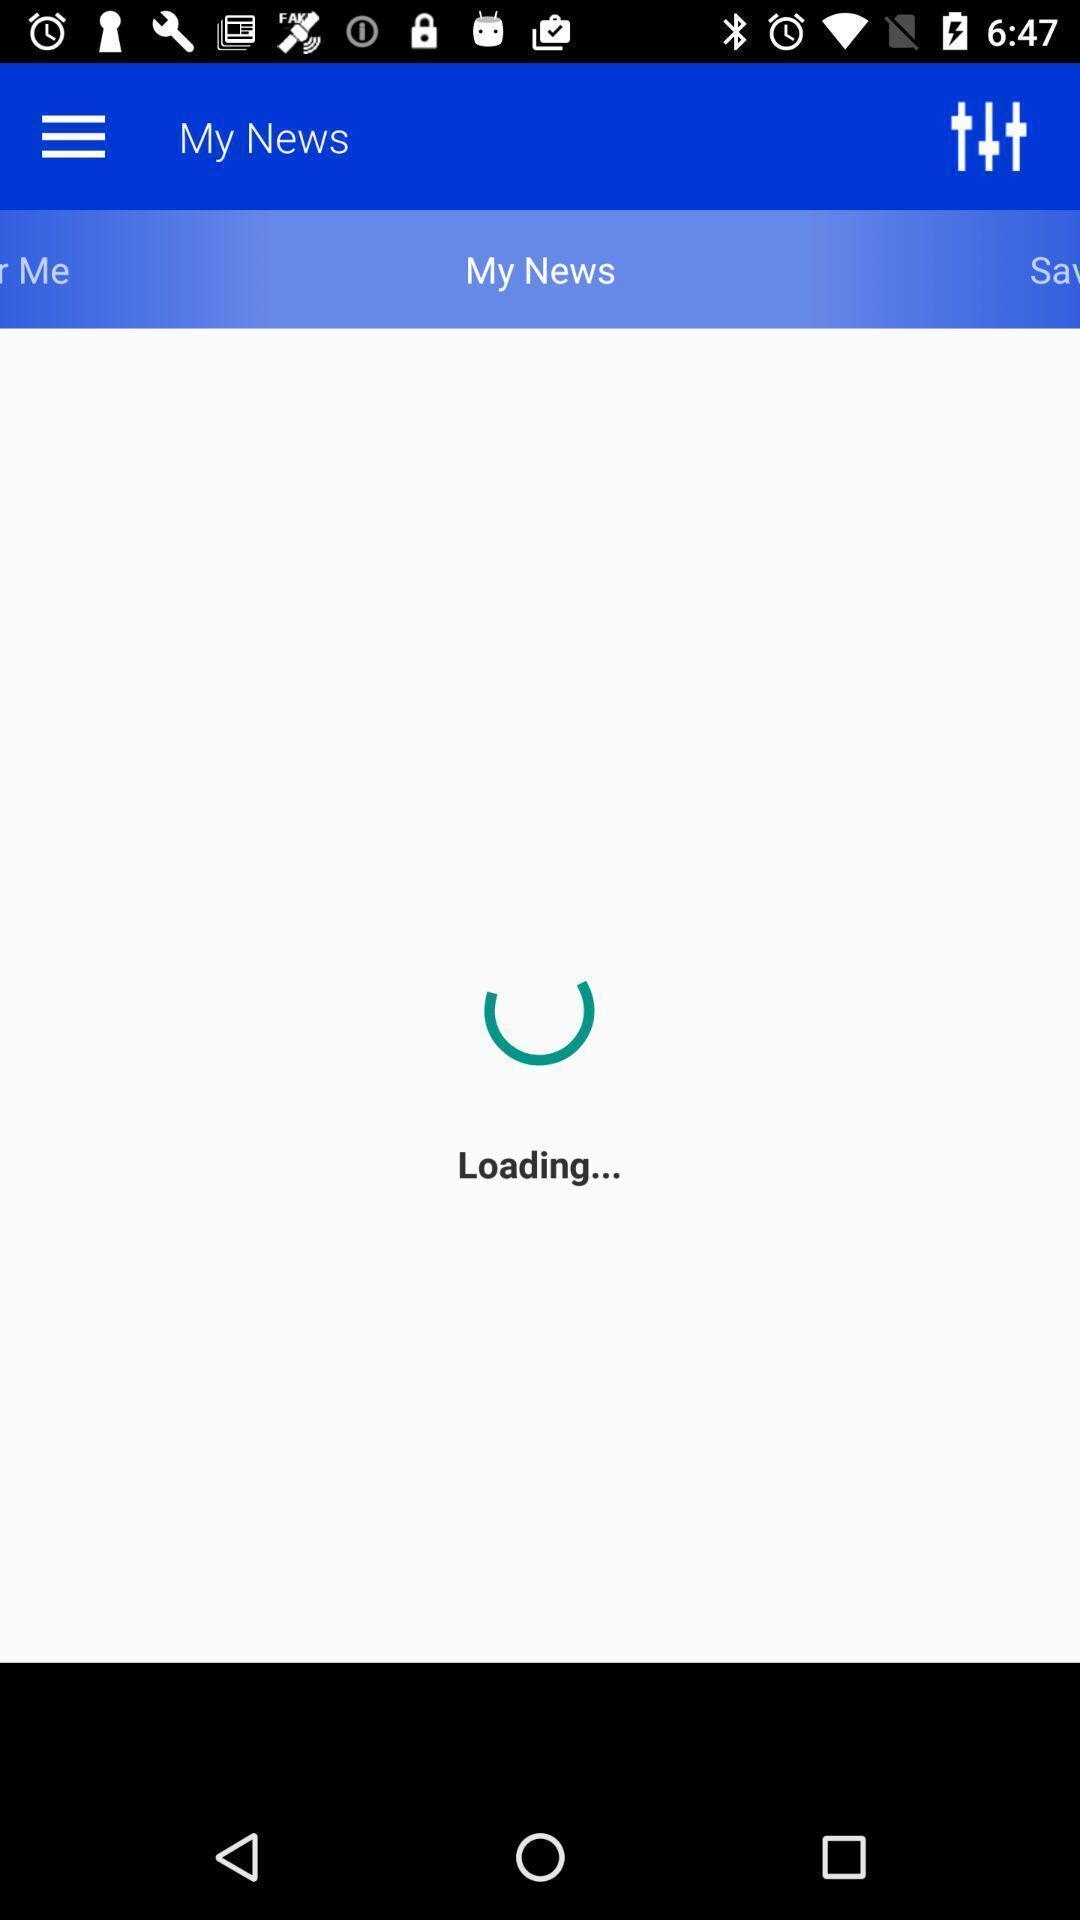What can you discern from this picture? Screen showing my news page in a news app. 